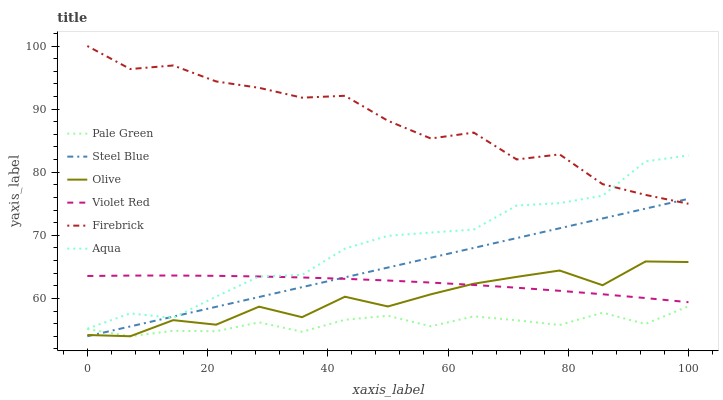Does Pale Green have the minimum area under the curve?
Answer yes or no. Yes. Does Firebrick have the maximum area under the curve?
Answer yes or no. Yes. Does Aqua have the minimum area under the curve?
Answer yes or no. No. Does Aqua have the maximum area under the curve?
Answer yes or no. No. Is Steel Blue the smoothest?
Answer yes or no. Yes. Is Olive the roughest?
Answer yes or no. Yes. Is Firebrick the smoothest?
Answer yes or no. No. Is Firebrick the roughest?
Answer yes or no. No. Does Steel Blue have the lowest value?
Answer yes or no. Yes. Does Aqua have the lowest value?
Answer yes or no. No. Does Firebrick have the highest value?
Answer yes or no. Yes. Does Aqua have the highest value?
Answer yes or no. No. Is Olive less than Aqua?
Answer yes or no. Yes. Is Firebrick greater than Violet Red?
Answer yes or no. Yes. Does Aqua intersect Violet Red?
Answer yes or no. Yes. Is Aqua less than Violet Red?
Answer yes or no. No. Is Aqua greater than Violet Red?
Answer yes or no. No. Does Olive intersect Aqua?
Answer yes or no. No. 